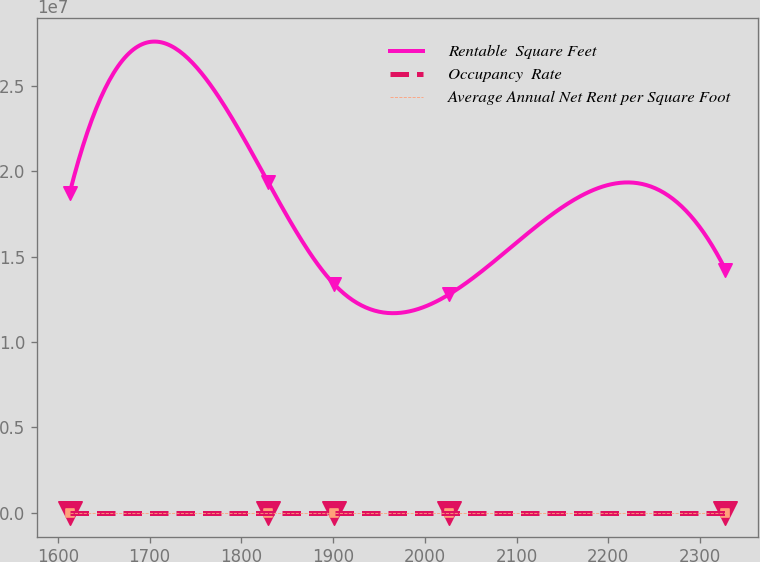<chart> <loc_0><loc_0><loc_500><loc_500><line_chart><ecel><fcel>Rentable  Square Feet<fcel>Occupancy  Rate<fcel>Average Annual Net Rent per Square Foot<nl><fcel>1612.93<fcel>1.8744e+07<fcel>76.04<fcel>18.01<nl><fcel>1828.98<fcel>1.93634e+07<fcel>103.22<fcel>16.04<nl><fcel>1900.46<fcel>1.34167e+07<fcel>106.83<fcel>17.32<nl><fcel>2026.81<fcel>1.27973e+07<fcel>112.15<fcel>11.74<nl><fcel>2327.73<fcel>1.42359e+07<fcel>82.57<fcel>10.95<nl></chart> 